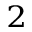Convert formula to latex. <formula><loc_0><loc_0><loc_500><loc_500>_ { 2 }</formula> 